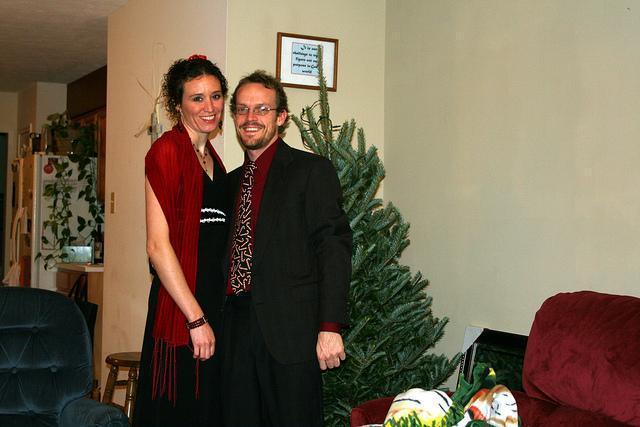How many people in the photo?
Give a very brief answer. 2. How many dresses are there?
Give a very brief answer. 1. How many people have red shirts?
Give a very brief answer. 1. How many real people are pictured?
Give a very brief answer. 2. How many party hats?
Give a very brief answer. 0. How many people are there?
Give a very brief answer. 2. 